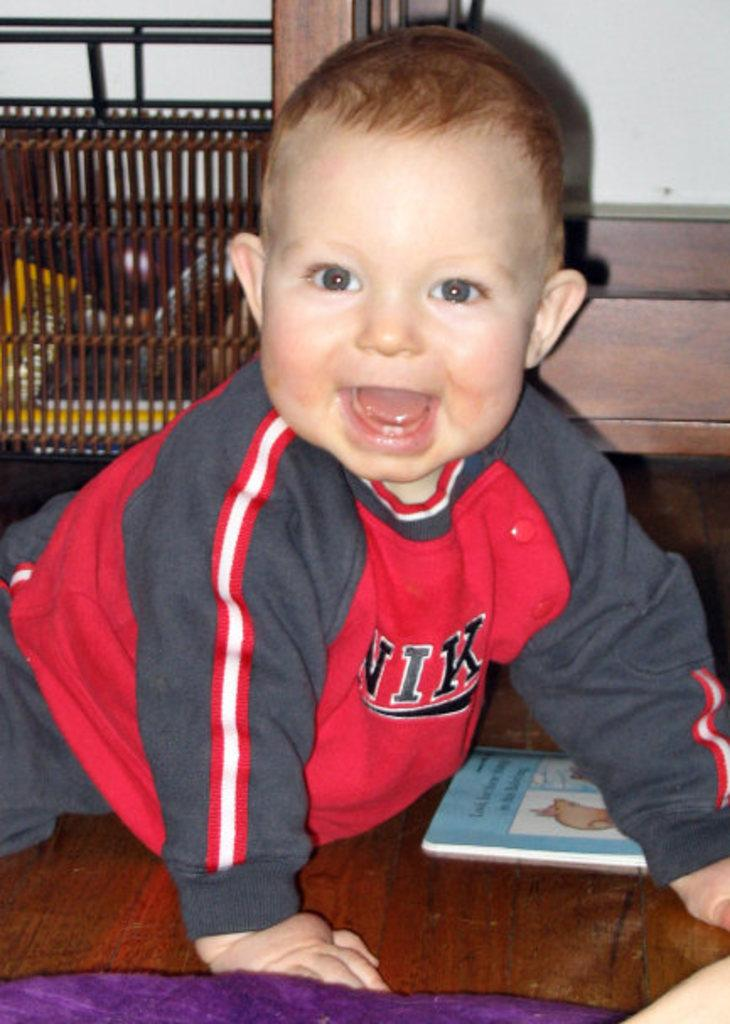<image>
Give a short and clear explanation of the subsequent image. A small child wearing a Nike sweatshirt crawls across the floor. 